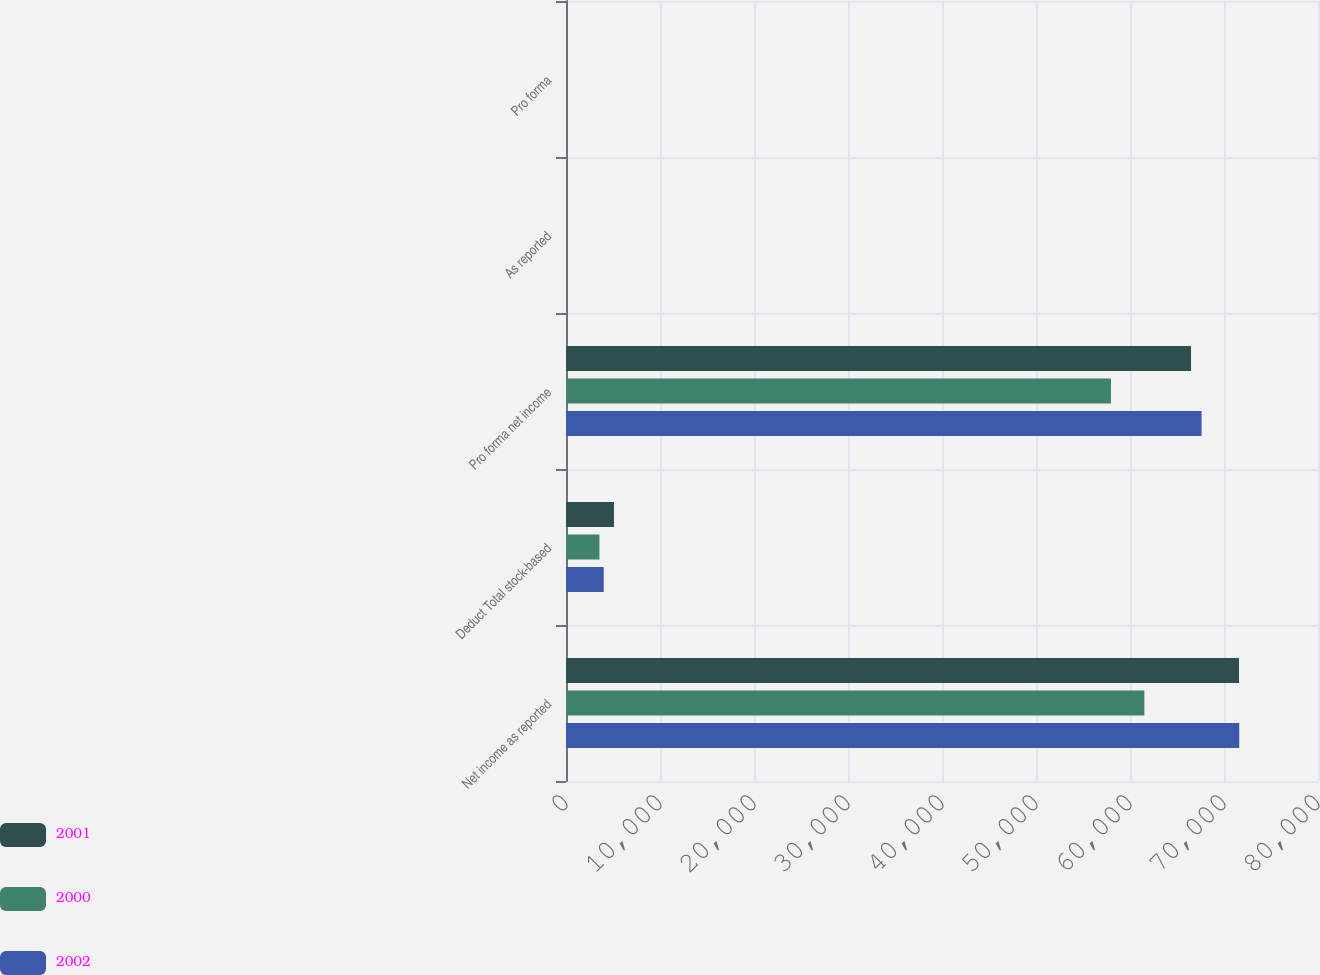<chart> <loc_0><loc_0><loc_500><loc_500><stacked_bar_chart><ecel><fcel>Net income as reported<fcel>Deduct Total stock-based<fcel>Pro forma net income<fcel>As reported<fcel>Pro forma<nl><fcel>2001<fcel>71595<fcel>5102<fcel>66493<fcel>2.31<fcel>2.15<nl><fcel>2000<fcel>61529<fcel>3558<fcel>57971<fcel>2.01<fcel>1.89<nl><fcel>2002<fcel>71622<fcel>4009<fcel>67613<fcel>2.33<fcel>2.2<nl></chart> 